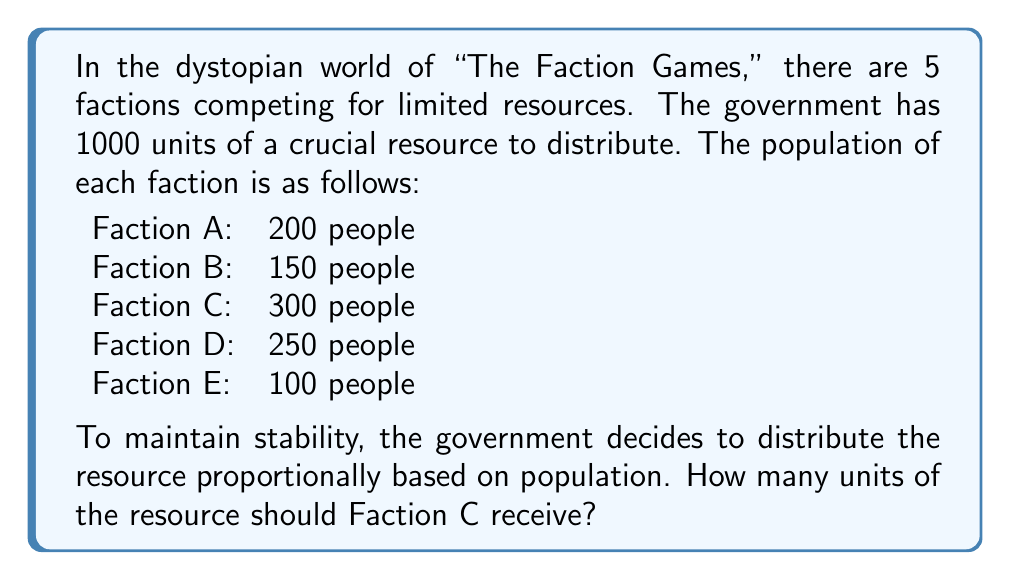Solve this math problem. To solve this problem, we need to follow these steps:

1. Calculate the total population:
   $$ \text{Total Population} = 200 + 150 + 300 + 250 + 100 = 1000 \text{ people} $$

2. Calculate the proportion of the population that Faction C represents:
   $$ \text{Faction C Proportion} = \frac{\text{Faction C Population}}{\text{Total Population}} = \frac{300}{1000} = 0.3 \text{ or } 30\% $$

3. Calculate the amount of resource Faction C should receive:
   $$ \text{Faction C Resource} = \text{Total Resource} \times \text{Faction C Proportion} $$
   $$ \text{Faction C Resource} = 1000 \times 0.3 = 300 \text{ units} $$

Therefore, Faction C should receive 300 units of the resource.
Answer: 300 units 